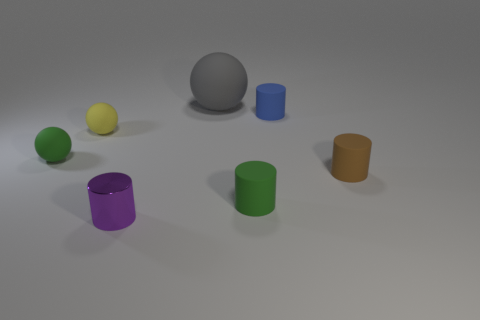Subtract all green rubber balls. How many balls are left? 2 Add 2 large rubber things. How many objects exist? 9 Subtract all brown cylinders. How many cylinders are left? 3 Subtract all yellow cylinders. How many purple spheres are left? 0 Subtract 1 balls. How many balls are left? 2 Subtract all gray cylinders. Subtract all blue cylinders. How many objects are left? 6 Add 7 gray matte balls. How many gray matte balls are left? 8 Add 3 gray matte cylinders. How many gray matte cylinders exist? 3 Subtract 0 yellow blocks. How many objects are left? 7 Subtract all cylinders. How many objects are left? 3 